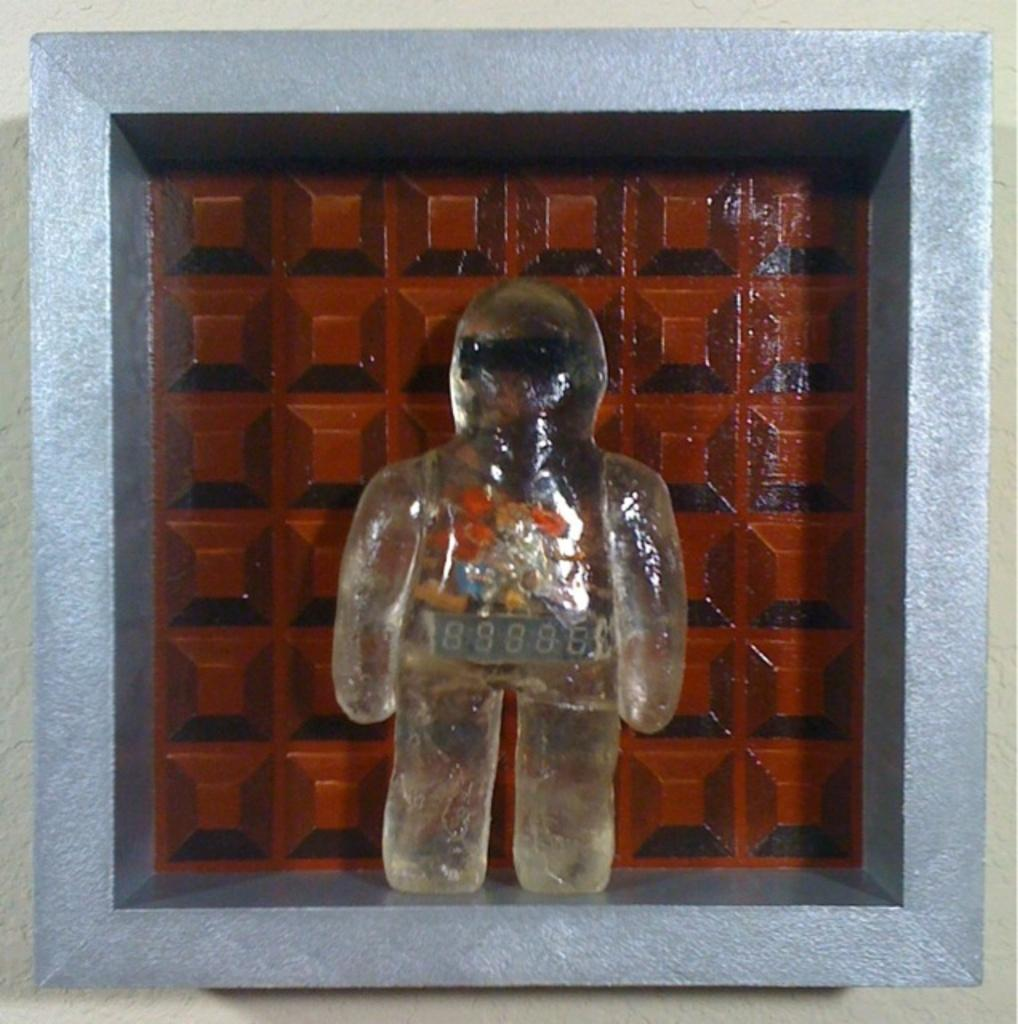What is the jelly in the image shaped like? The jelly in the image is in the form of a person. Where is the jelly located in the image? The jelly is present in a box. What is the zinc content of the jelly in the image? There is no information about the zinc content of the jelly in the image, as it is not relevant to the image's content. --- Transcript: In this image we can see a person holding a camera and taking a picture. There is a building in the background. Facts: 1. There is a person in the image. 2. The person is holding a camera. 3. The person is taking a picture. 4. There is a building in the background of the image. Conversation: What is the person in the image doing? The person in the image is holding a camera and taking a picture. What can be seen in the background of the image? There is a building in the background of the image. How many people are present in the image? There is only one person present in the image. Reasoning: Let's think step by step in order to produce the conversation. We start by identifying the main subject in the image, which is the person holding the camera. Then, we expand the conversation to include the action the person is performing (taking a picture) and the background of the image (a building). Each question is designed to elicit a specific detail about the image that is known from the provided facts. Absurd Question/Answer: How many years has the building in the background been standing? There is no information about the age of the building in the image, as it is not relevant to the image's content. --- Transcript: In this picture we can see a person sitting on a chair and reading a book. There is a table next to the chair. Facts: 1. There is a person in the image. 2. The person is sitting on a chair. 3. The person is reading a book. 4. There is a table next to the chair. Conversation: What is the person in the image doing? The person in the image is sitting on a chair and reading a book. What can be seen next to the chair in the image? There is a table next to the chair in the image. What might the person be using to support their book while reading? The table next to the chair could be used to support the book while the person is reading. Reasoning: Let's think step by step in order to produce the conversation. We start by identifying the main subject in the image, which is the person sitting on the chair. Then, we expand the conversation to include the action the person is performing (reading a book) and the presence of a table next to the chair. Each question is designed to elicit a specific detail about the image that is known from the provided facts. 